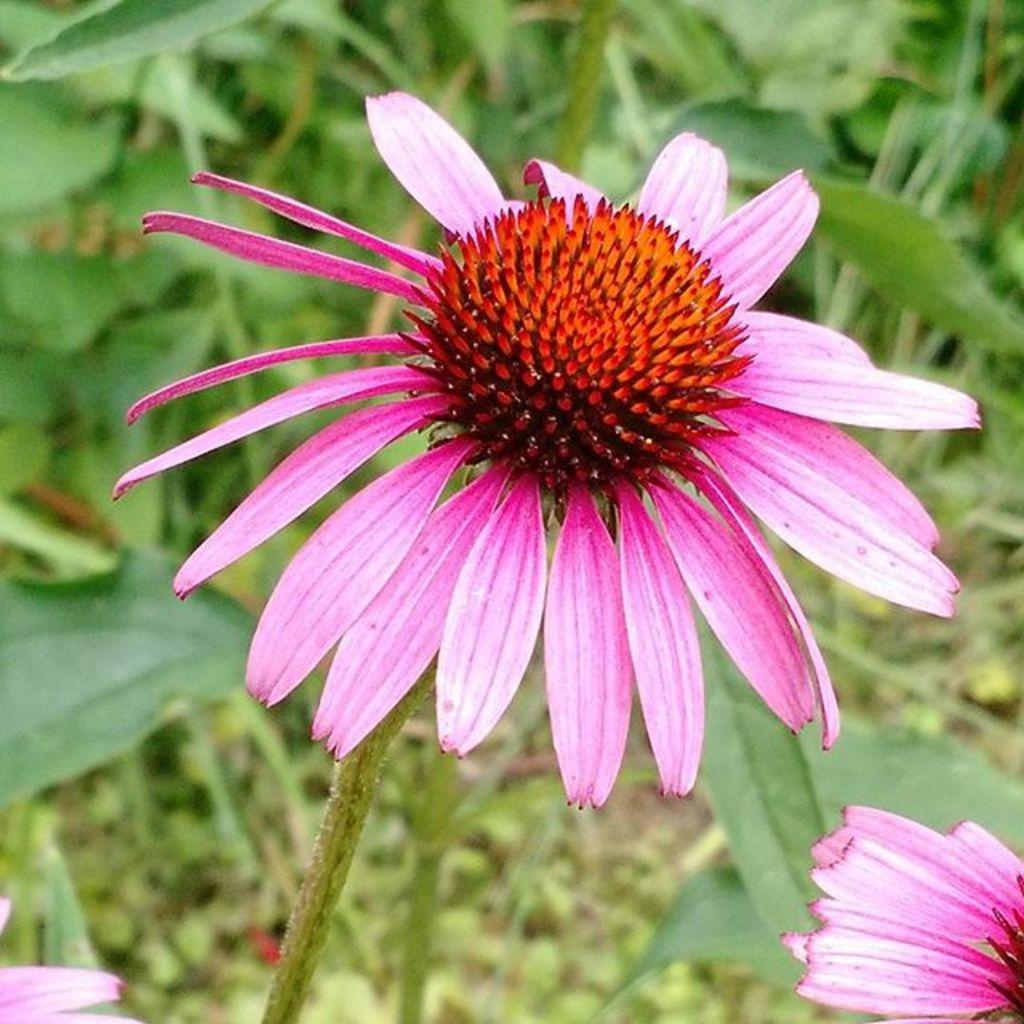What type of flower can be seen in the image? There is a pink flower in the image. Where is the flower located on the plant? The flower is on the stem of a plant. What can be seen in the background of the image? There is a group of plants in the background of the image. What type of cushion is being used to support the bear in the image? There is no bear or cushion present in the image; it features a pink flower on a plant. 